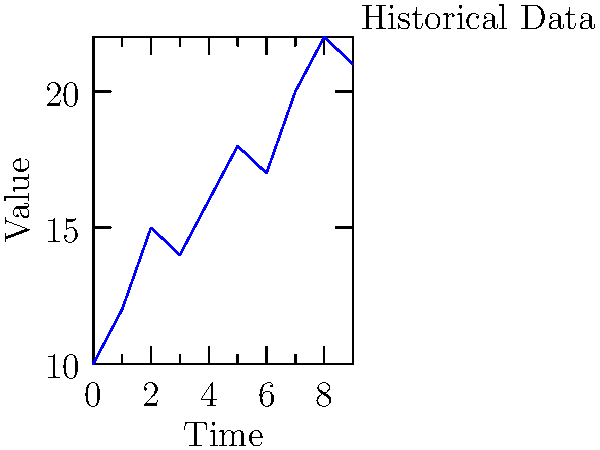Given the historical time series data shown in the graph, which of the following LSTM network architectures would be most suitable for forecasting the next 3 time steps, considering the React and Meteor ecosystem?

A) Single-layer LSTM with 64 units
B) Stacked LSTM with 3 layers, each having 32 units
C) Bidirectional LSTM with 2 layers, each having 48 units
D) CNN-LSTM hybrid with 1D convolutions followed by LSTM layer To answer this question, let's consider the following steps:

1) Analyze the data: The graph shows a time series with a generally increasing trend but some fluctuations.

2) Consider the problem: We need to forecast the next 3 time steps, which is a relatively short-term prediction.

3) LSTM capabilities: LSTMs are good at capturing long-term dependencies in sequential data.

4) React and Meteor context: These are JavaScript frameworks, so we should consider solutions that integrate well with JavaScript.

5) Evaluate each option:
   A) Single-layer LSTM: Simple but might not capture complex patterns.
   B) Stacked LSTM: Can learn more complex features but might be overkill.
   C) Bidirectional LSTM: Good for capturing both past and future context, but unnecessary for forecasting.
   D) CNN-LSTM hybrid: CNNs can extract local features, which can be useful for time series.

6) Integration with React/Meteor: Option D (CNN-LSTM) can be efficiently implemented using TensorFlow.js, which integrates well with React and Meteor.

7) Final consideration: The CNN-LSTM hybrid can capture both local patterns (via CNN) and long-term dependencies (via LSTM), making it suitable for this forecasting task.

Therefore, the most suitable architecture for this scenario is the CNN-LSTM hybrid.
Answer: D) CNN-LSTM hybrid with 1D convolutions followed by LSTM layer 